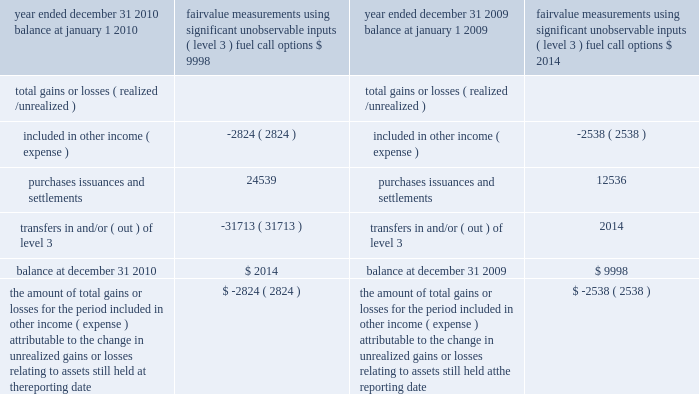Notes to the consolidated financial statements non-financial assets and liabilities measured at fair value on a non-recurring basis during 2009 , we classified the atlantic star as held for sale and recognized a charge of $ 7.1 million to reduce the carrying value of the ship to its fair value less cost to sell based on a firm offer received during 2009 .
This amount was recorded within other operating expenses in our consolidated statement of operations .
We determined the fair market value of the atlantic star as of december 31 , 2010 based on comparable ship sales adjusted for the condition , age and size of the ship .
We have categorized these inputs as level 3 because they are largely based on our own assump- tions .
As of december 31 , 2010 , the carrying amount of the atlantic star which we still believe represents its fair value was $ 46.4 million .
The table presents a reconciliation of the company 2019s fuel call options 2019 beginning and ending balances as follows ( in thousands ) : fair value fair value measurements measurements using significant using significant unobservable unobservable year ended december 31 , 2010 inputs ( level 3 ) year ended december 31 , 2009 inputs ( level 3 ) fuel call options fuel call options balance at january 1 , 2010 $ 9998 balance at january 1 , 2009 $ 2007 2007 2007 2007 2014 total gains or losses ( realized/ unrealized ) total gains or losses ( realized/ unrealized ) .
The amount of total gains or losses for the period included in other income ( expense ) attributable to the change in unrealized gains or losses relating to assets still held at the reporting date $ ( 2824 ) the amount of total gains or losses for the period included in other income ( expense ) attributable to the change in unrealized gains or losses relating to assets still held at the reporting date $ ( 2538 ) during the fourth quarter of 2010 , we changed our valuation technique for fuel call options to a market approach method which employs inputs that are observable .
The fair value for fuel call options is determined by using the prevailing market price for the instruments consisting of published price quotes for similar assets based on recent transactions in an active market .
We believe that level 2 categorization is appropriate due to an increase in the observability and transparency of significant inputs .
Previously , we derived the fair value of our fuel call options using standard option pricing models with inputs based on the options 2019 contract terms and data either readily available or formulated from public market informa- tion .
The fuel call options were categorized as level 3 because certain inputs , principally volatility , were unobservable .
Net transfers in and/or out of level 3 are reported as having occurred at the end of the quarter in which the transfer occurred ; therefore , gains or losses reflected in the table above for 2010 include fourth quarter fuel call option gains or losses .
The reported fair values are based on a variety of factors and assumptions .
Accordingly , the fair values may not represent actual values of the financial instru- ments and long-lived assets that could have been realized as of december 31 , 2010 or december 31 , 2009 , or that will be realized in the future and do not include expenses that could be incurred in an actual sale or settlement .
Derivative instruments we are exposed to market risk attributable to changes in interest rates , foreign currency exchange rates and fuel prices .
We manage these risks through a combi- nation of our normal operating and financing activities and through the use of derivative financial instruments pursuant to our hedging practices and policies .
The financial impact of these hedging instruments is pri- marily offset by corresponding changes in the under- lying exposures being hedged .
We achieve this by closely matching the amount , term and conditions of the derivative instrument with the underlying risk being hedged .
We do not hold or issue derivative financial instruments for trading or other speculative purposes .
We monitor our derivative positions using techniques including market valuations and sensitivity analyses. .
What percent did purchase issuances and settlements increase from year ended 2009 to year ended 2010? 
Computations: (((24539 - 12536) / 12536) * 100)
Answer: 95.74825. 